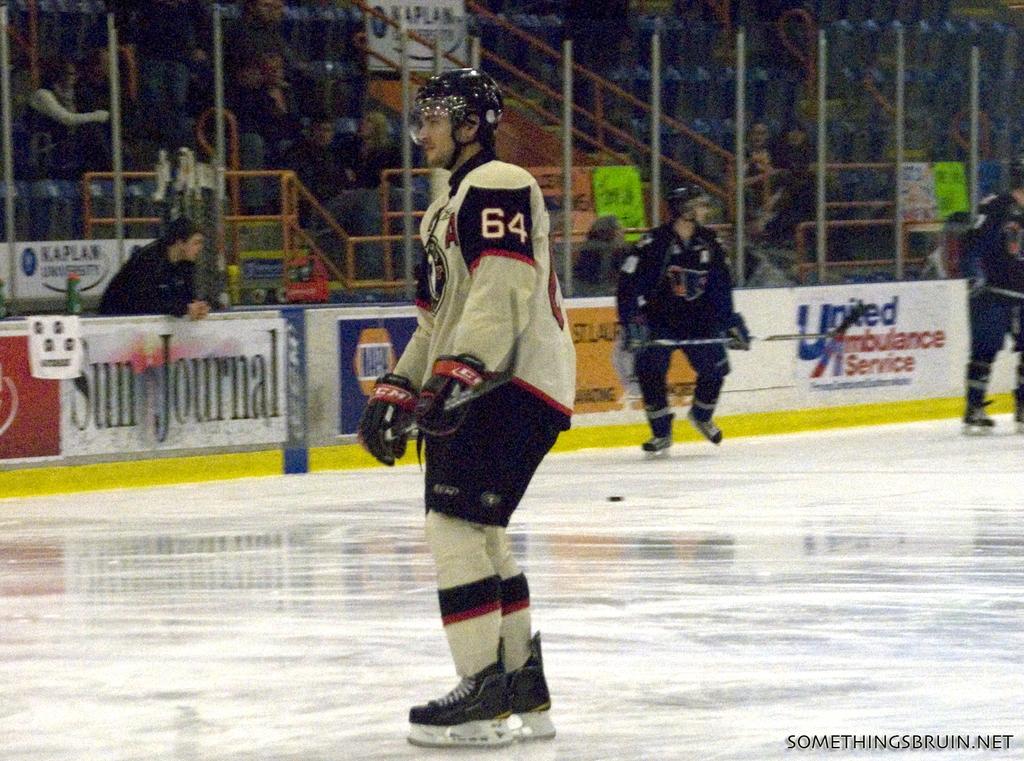What is the number of the hockey player in white?
Provide a short and direct response. 64. What does the ad at the far left end say?
Give a very brief answer. Sun journal. 